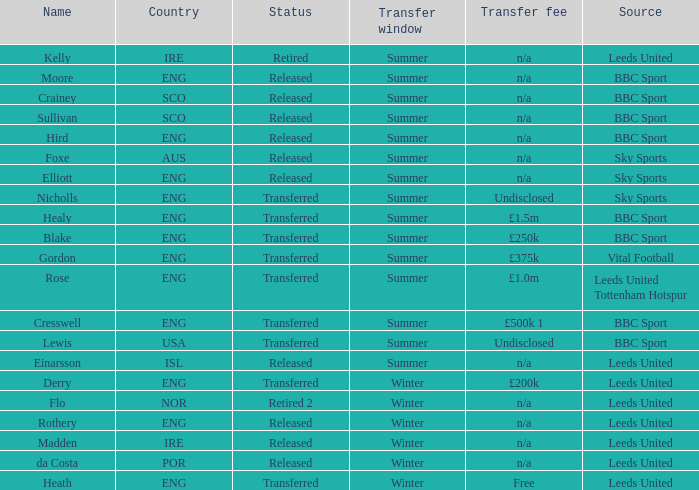What is the person's name that is from the country of SCO? Crainey, Sullivan. 